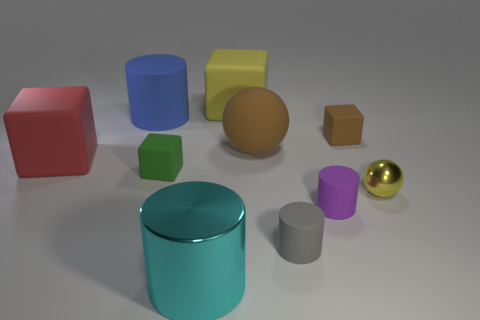Are there the same number of brown rubber objects in front of the tiny green rubber block and small brown cubes that are behind the tiny shiny thing?
Your answer should be compact. No. What number of cyan shiny cubes are there?
Your response must be concise. 0. Is the number of cubes that are on the left side of the purple rubber cylinder greater than the number of yellow things?
Your answer should be very brief. Yes. What is the big thing in front of the tiny yellow object made of?
Offer a very short reply. Metal. What is the color of the other small rubber object that is the same shape as the tiny green rubber thing?
Give a very brief answer. Brown. What number of other small spheres are the same color as the small sphere?
Your answer should be very brief. 0. There is a metal thing that is to the left of the big brown sphere; is it the same size as the shiny object behind the metal cylinder?
Keep it short and to the point. No. There is a green cube; is its size the same as the metallic object to the left of the tiny metal thing?
Ensure brevity in your answer.  No. What size is the blue cylinder?
Provide a succinct answer. Large. There is a big sphere that is made of the same material as the green cube; what color is it?
Make the answer very short. Brown. 